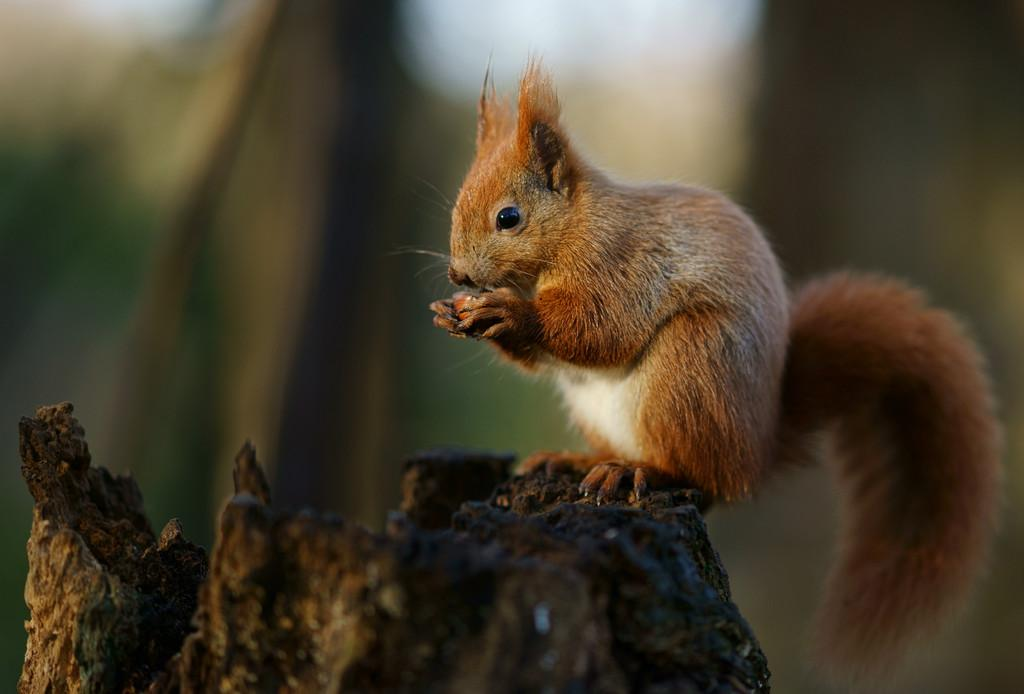What animal is in the image? There is a squirrel in the image. Where is the squirrel located? The squirrel is sitting on a branch. What colors can be seen on the squirrel? The squirrel has brown and white coloring. How would you describe the background of the image? The background of the image is blurred. Is the squirrel sitting on a table in the image? No, the squirrel is sitting on a branch, not a table. 